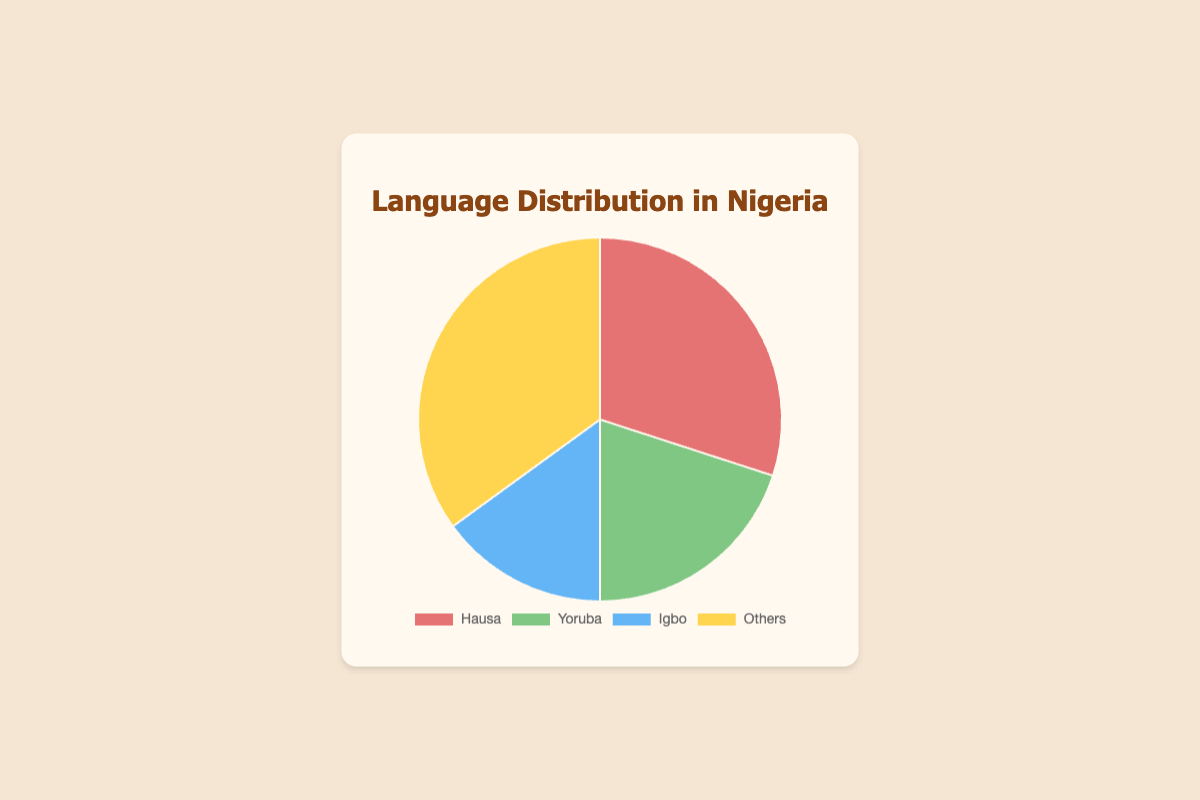What percentage of the pie chart does "Others" represent? The segment labeled "Others" represents 35% of the pie chart. This is directly given in the data used to create the pie chart, where "Others" includes the ethnic groups Fulani, Tiv, Ijaw, Kanuri, and Ibibio, collectively making up 35%.
Answer: 35% Which ethnic group has the highest percentage? The ethnic group with the highest percentage in the pie chart is Hausa, which occupies 30% of the chart. This can be confirmed by looking at the largest segment of the pie chart and referring to the labels.
Answer: Hausa How does the percentage of Yoruba compare to Igbo? The percentage of Yoruba (20%) is higher than that of Igbo (15%). By visually comparing the sizes of the segments and checking the labels, it is evident that the Yoruba segment is larger by 5%.
Answer: Yoruba has 5% more What is the combined percentage of Hausa and Yoruba? To find the combined percentage of Hausa and Yoruba, add their respective percentages: 30% + 20% = 50%. This involves a simple addition of the two segments.
Answer: 50% What color represents the Yoruba segment in the pie chart? The Yoruba segment is represented by the green color in the pie chart. This can be identified by matching the segment labeled "Yoruba" to its corresponding color.
Answer: Green Which ethnic groups are included in the "Others" category? The "Others" category includes Fulani, Tiv, Ijaw, Kanuri, and Ibibio ethnic groups. The pie chart consolidates these smaller groups into one segment labeled "Others".
Answer: Fulani, Tiv, Ijaw, Kanuri, and Ibibio What is the proportion of Hausa compared to the total "Others" category? The percentage of the Hausa segment is 30%. The "Others" category is 35%. To find the proportion, divide the percentage of Hausa by the percentage of "Others": 30% / 35% ≈ 0.857, which is approximately 86%. This requires both division and multiplication to convert the answer into a percentage.
Answer: 86% If the percentages given for Fulani (10%), Tiv (5%), Ijaw (10%), Kanuri (5%), and Ibibio (5%) are accurate, is the "Others" percentage correct? By adding the percentages of Fulani (10%), Tiv (5%), Ijaw (10%), Kanuri (5%), and Ibibio (5%): 10% + 5% + 10% + 5% + 5% = 35%. The total matches the percentage given for "Others" in the pie chart, verifying it is correct.
Answer: Yes, it is correct 